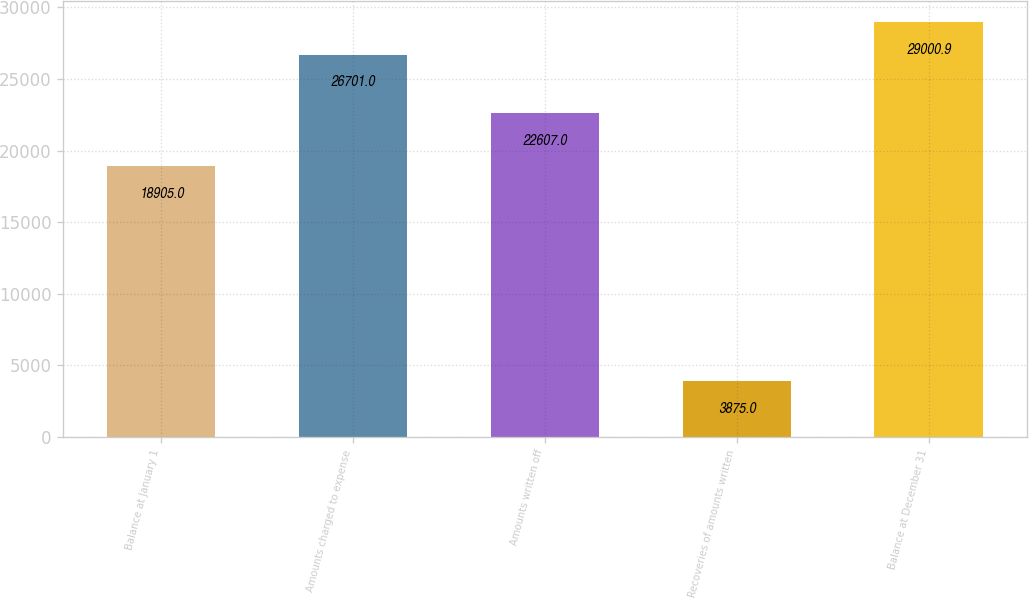Convert chart. <chart><loc_0><loc_0><loc_500><loc_500><bar_chart><fcel>Balance at January 1<fcel>Amounts charged to expense<fcel>Amounts written off<fcel>Recoveries of amounts written<fcel>Balance at December 31<nl><fcel>18905<fcel>26701<fcel>22607<fcel>3875<fcel>29000.9<nl></chart> 